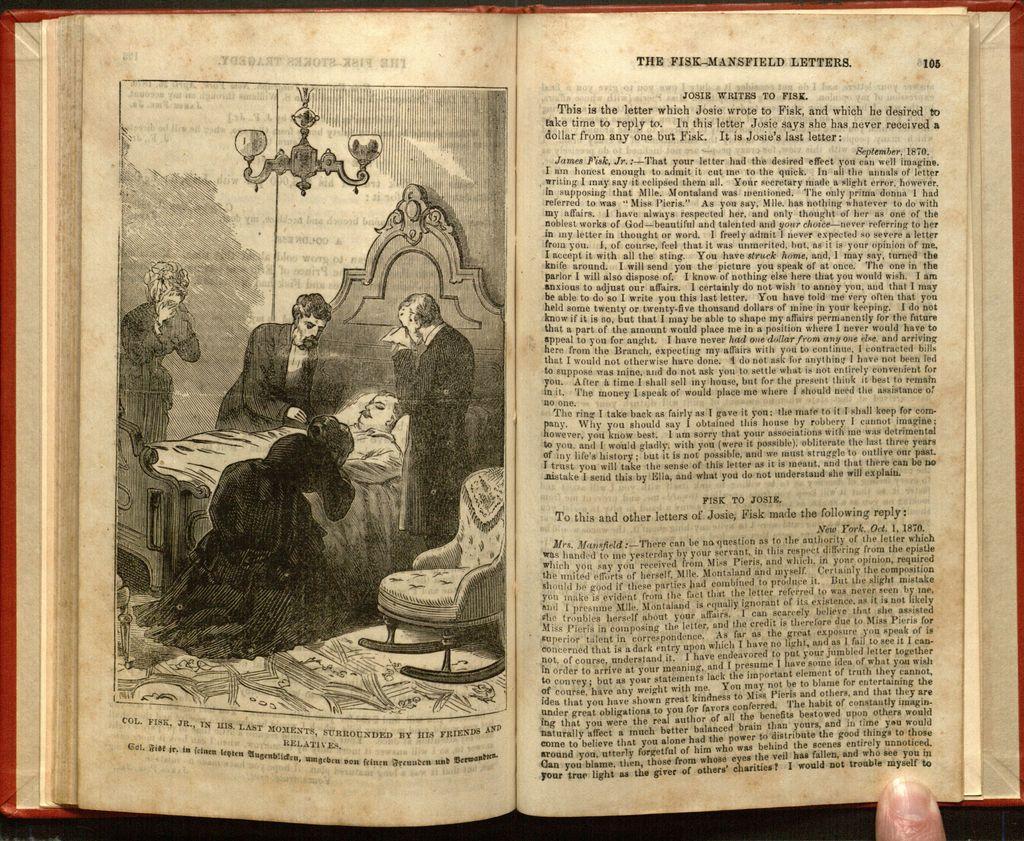In one or two sentences, can you explain what this image depicts? In this picture we can see a photograph of the old book. On the left side there is a man lying on the bed, beside we can see some people standing and crying. 